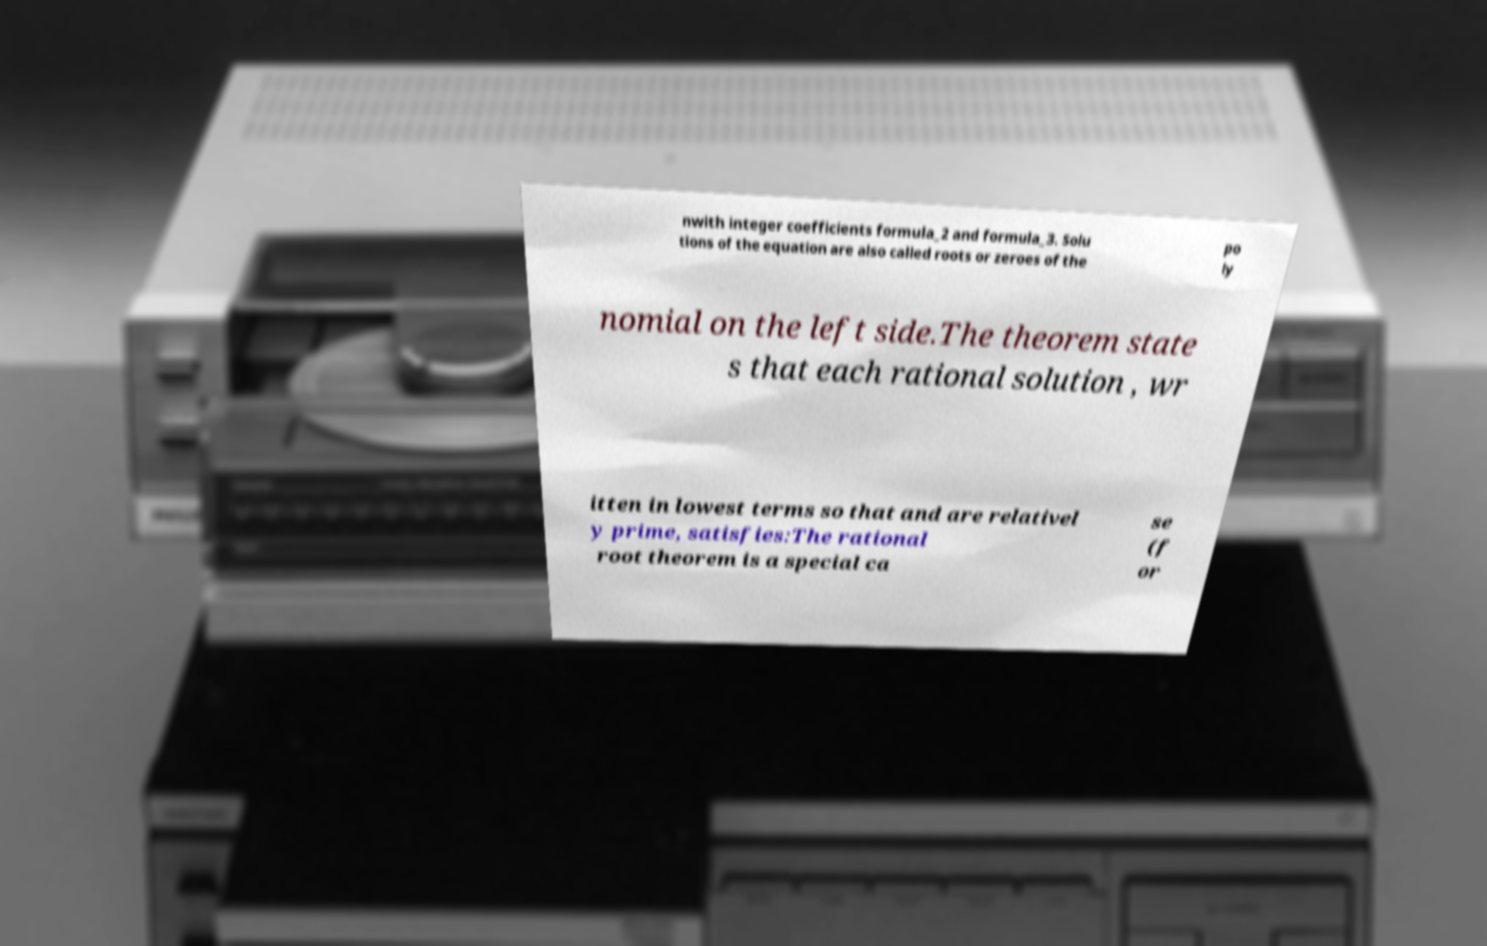Can you accurately transcribe the text from the provided image for me? nwith integer coefficients formula_2 and formula_3. Solu tions of the equation are also called roots or zeroes of the po ly nomial on the left side.The theorem state s that each rational solution , wr itten in lowest terms so that and are relativel y prime, satisfies:The rational root theorem is a special ca se (f or 